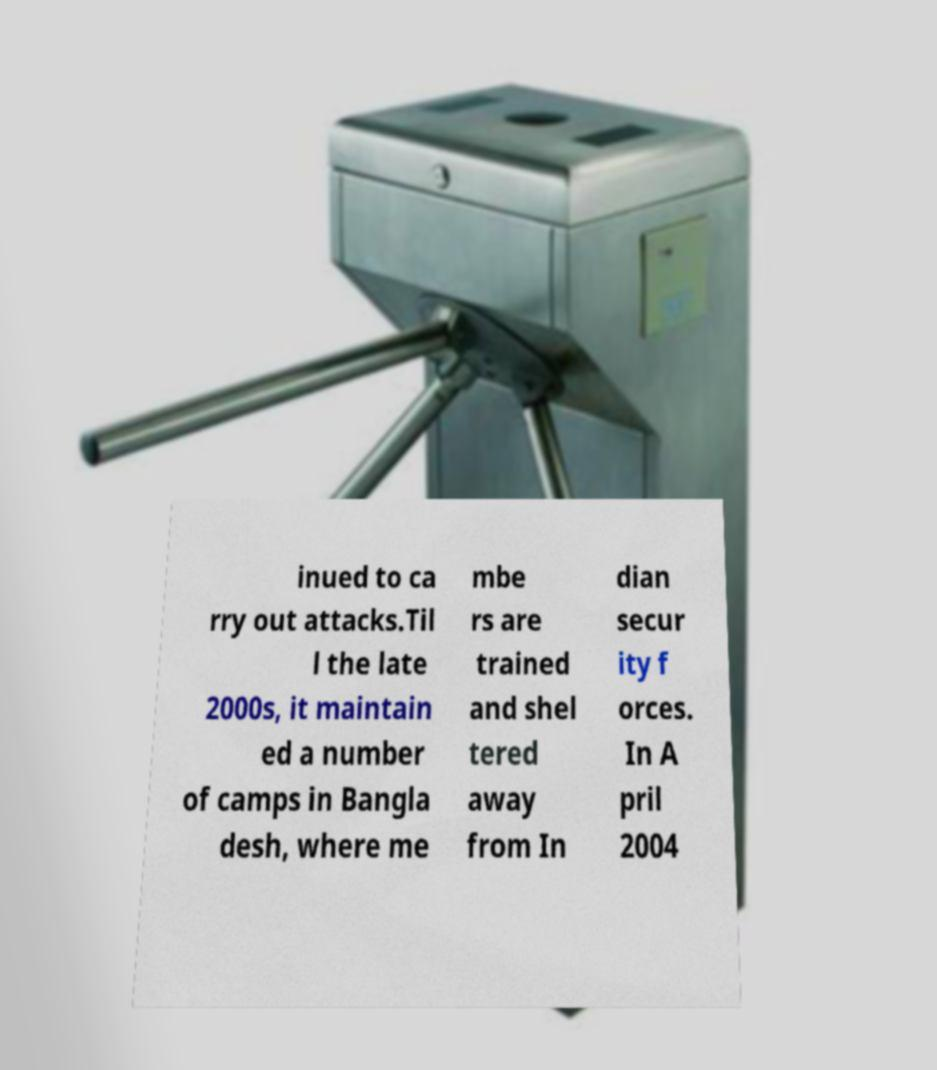I need the written content from this picture converted into text. Can you do that? inued to ca rry out attacks.Til l the late 2000s, it maintain ed a number of camps in Bangla desh, where me mbe rs are trained and shel tered away from In dian secur ity f orces. In A pril 2004 